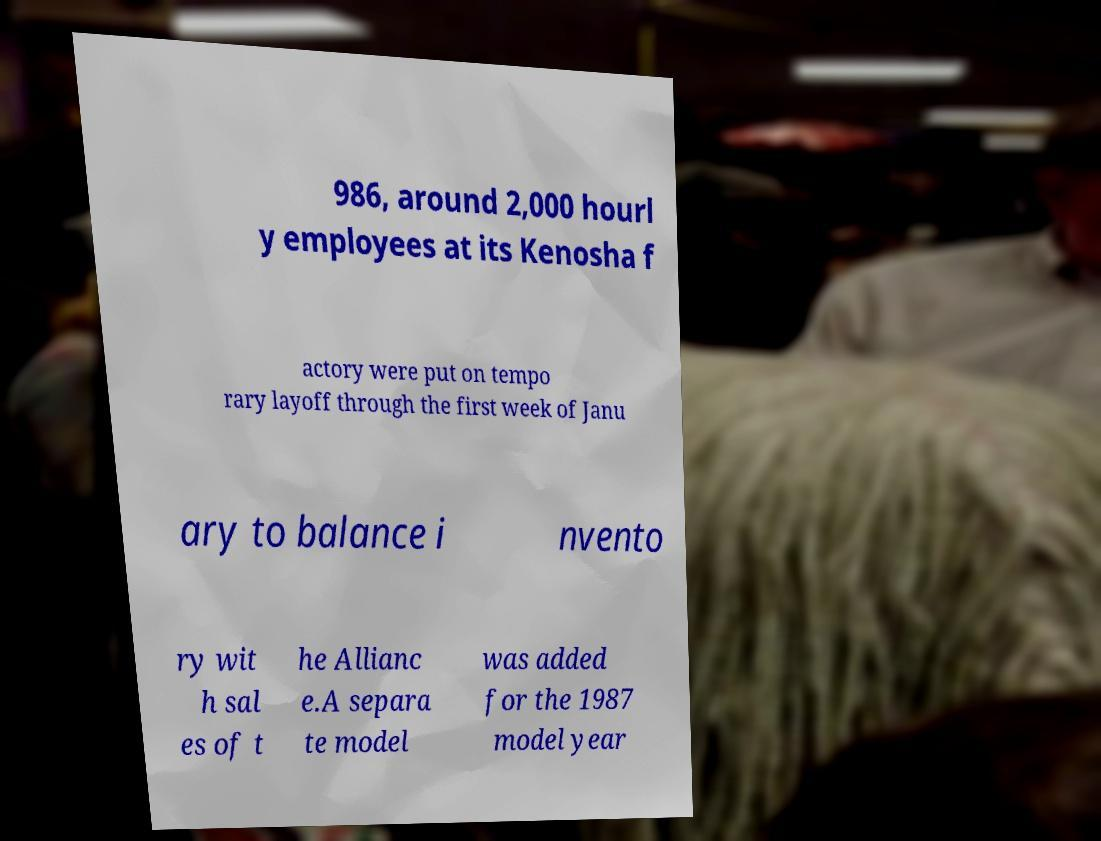What messages or text are displayed in this image? I need them in a readable, typed format. 986, around 2,000 hourl y employees at its Kenosha f actory were put on tempo rary layoff through the first week of Janu ary to balance i nvento ry wit h sal es of t he Allianc e.A separa te model was added for the 1987 model year 